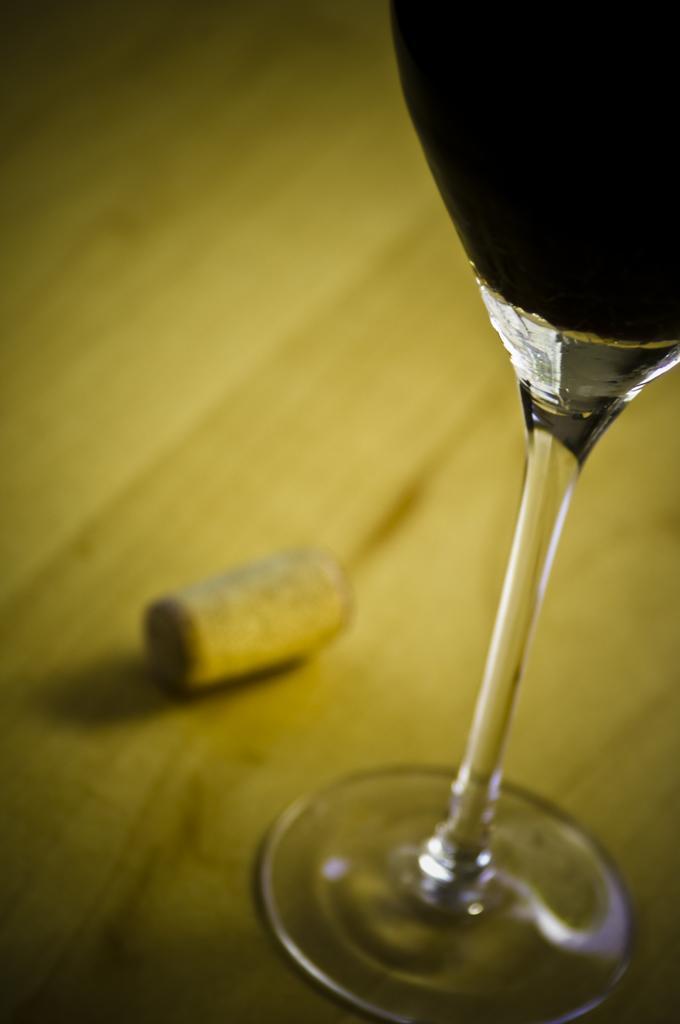Describe this image in one or two sentences. In this picture we can see a glass with drink on a platform. 